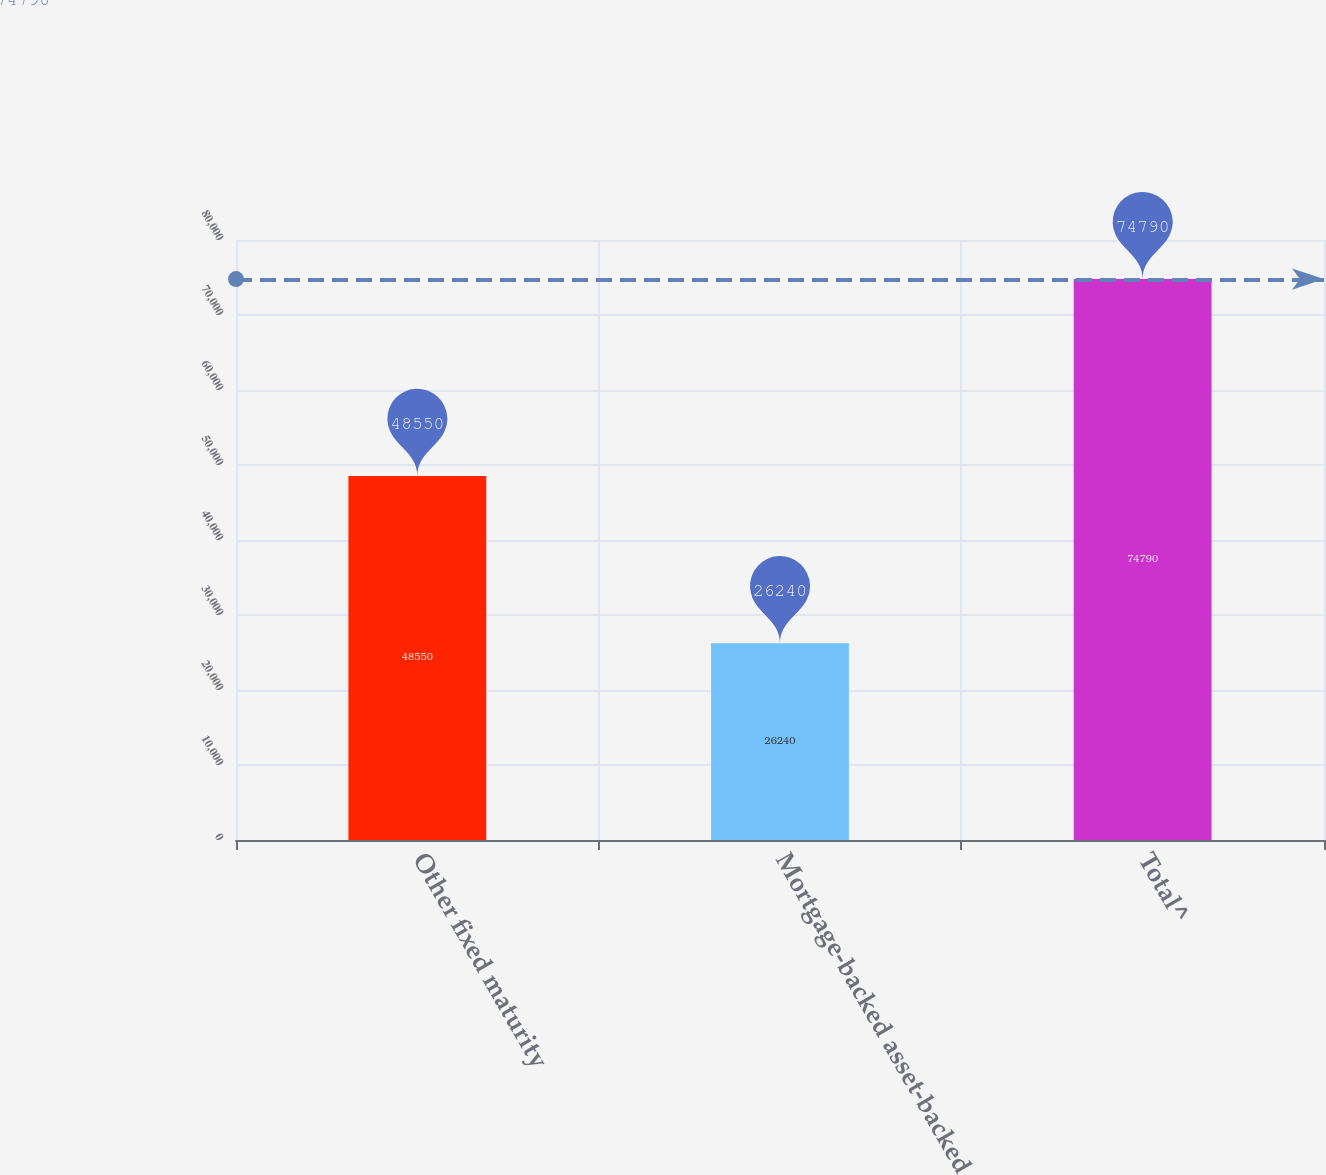Convert chart. <chart><loc_0><loc_0><loc_500><loc_500><bar_chart><fcel>Other fixed maturity<fcel>Mortgage-backed asset-backed<fcel>Total^<nl><fcel>48550<fcel>26240<fcel>74790<nl></chart> 